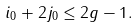Convert formula to latex. <formula><loc_0><loc_0><loc_500><loc_500>i _ { 0 } + 2 j _ { 0 } \leq 2 g - 1 .</formula> 